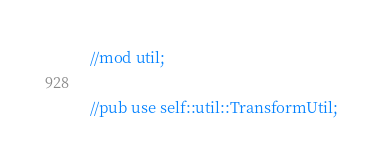<code> <loc_0><loc_0><loc_500><loc_500><_Rust_>//mod util;

//pub use self::util::TransformUtil;</code> 